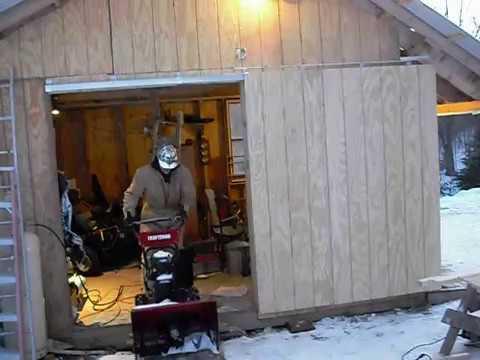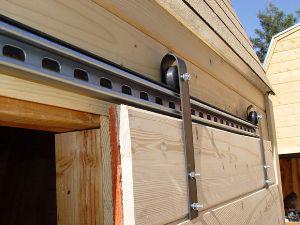The first image is the image on the left, the second image is the image on the right. Assess this claim about the two images: "An image depicts a barn door with diagonal crossed boards on the front.". Correct or not? Answer yes or no. No. 